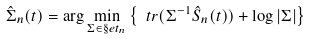<formula> <loc_0><loc_0><loc_500><loc_500>\hat { \Sigma } _ { n } ( t ) = \arg \min _ { \Sigma \in \S e t _ { n } } \left \{ \ t r ( \Sigma ^ { - 1 } \hat { S } _ { n } ( t ) ) + \log | \Sigma | \right \}</formula> 